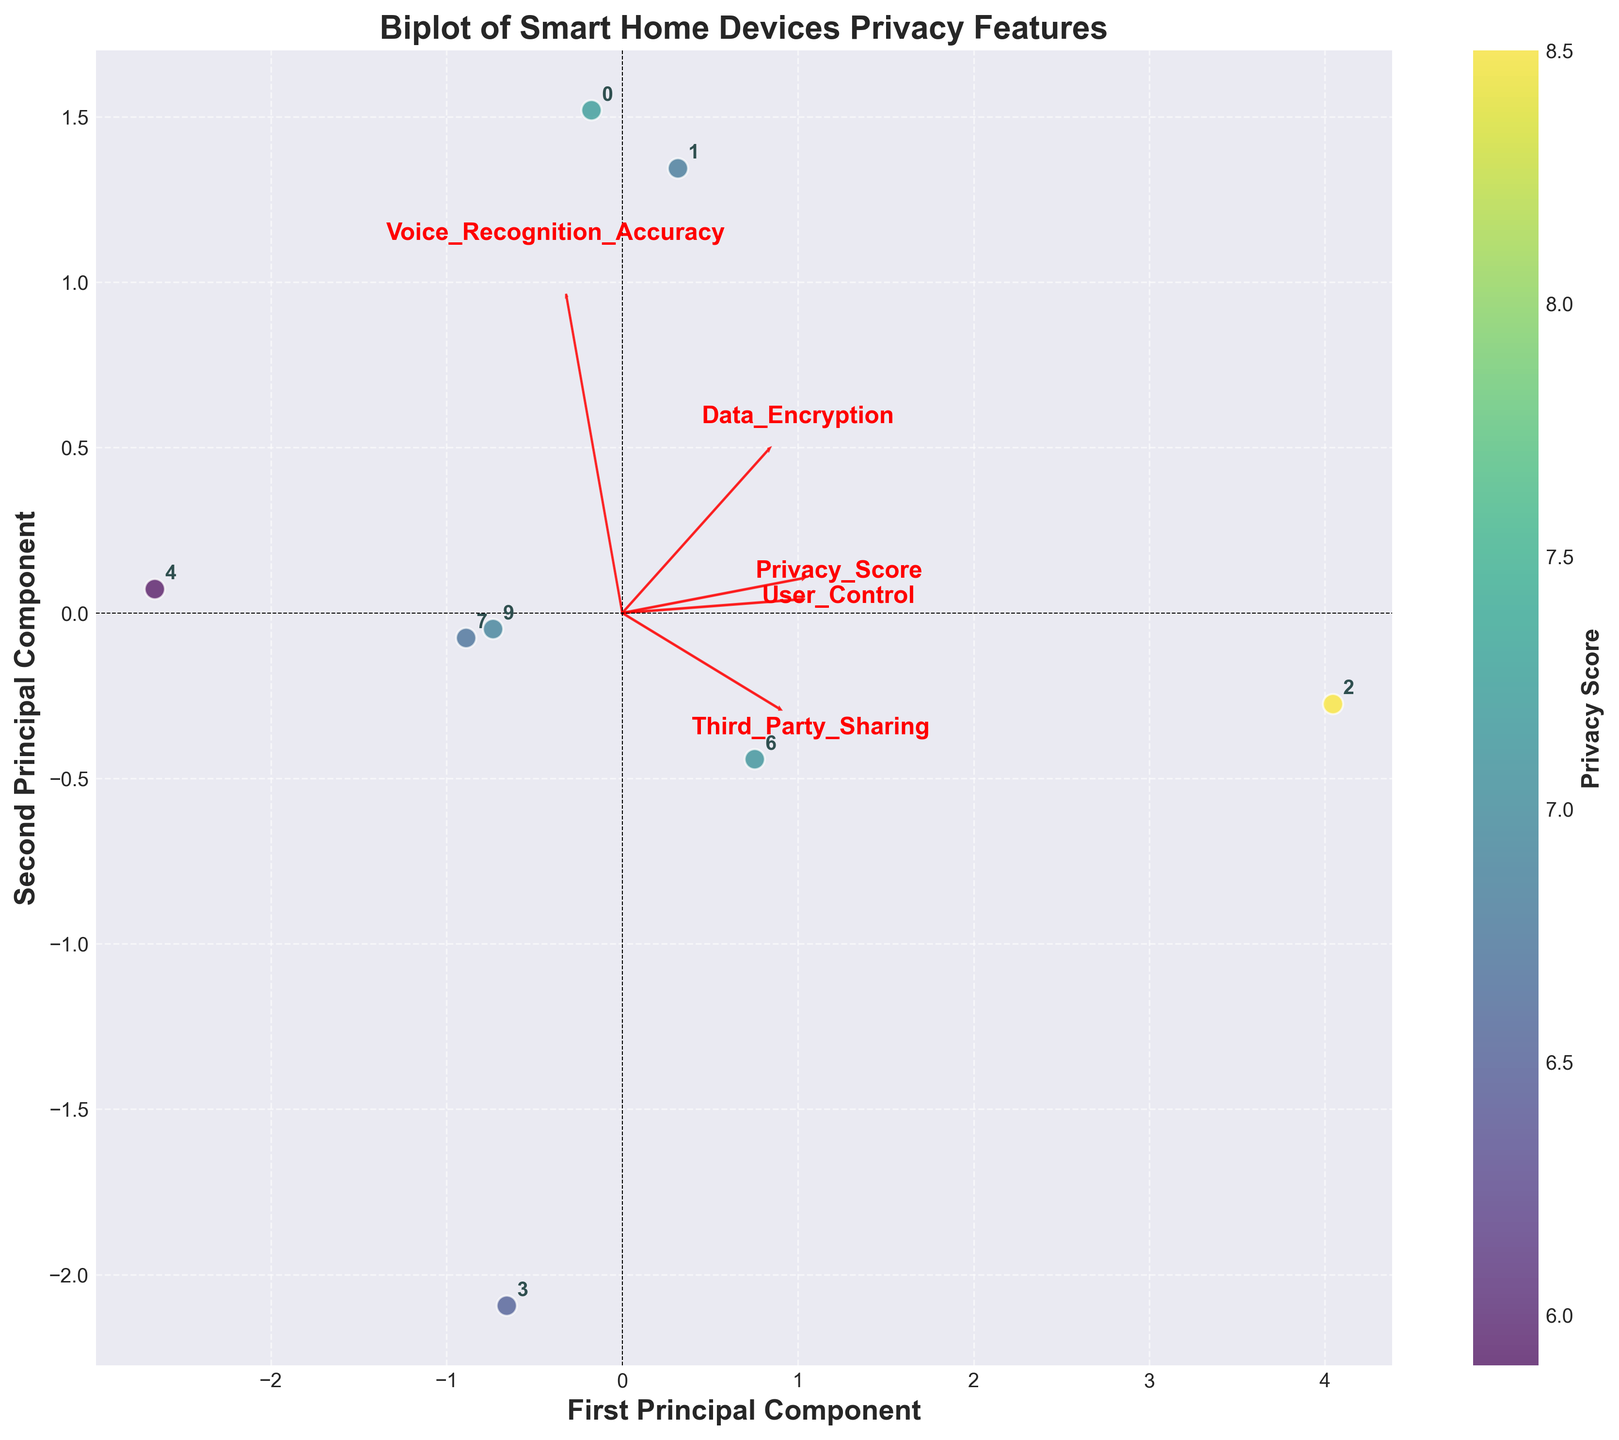What title is given to the plot? The title is prominently displayed at the top of the figure.
Answer: Biplot of Smart Home Devices Privacy Features How many principal components are plotted on the axes? The axes are labeled with "First Principal Component" and "Second Principal Component," indicating two principal components.
Answer: Two Which device has the highest Privacy Score indicated by the color gradient? By looking at the color gradient and the scatter points, the device with the highest Privacy Score corresponds to the darkest color.
Answer: Apple HomePod How does "Voice Recognition Accuracy" relate to the principal components? The feature loadings for "Voice Recognition Accuracy" can be determined by the red arrow labeled accordingly.
Answer: It points towards the first principal component Which two features are most closely aligned with the first principal component? The direction and length of the red arrows indicate the alignments of features with the principal components.
Answer: Data Encryption and Voice Recognition Accuracy What is the general direction of the "Third Party Sharing" feature relative to the principal components? The red arrow for "Third Party Sharing" shows its direction with respect to the origin.
Answer: Mostly along the second principal component Where is the "Samsung SmartThings Hub" located in the context of the principal components? The labeled scatter plot points can be identified with the X and Y coordinates for the Samsung SmartThings Hub.
Answer: Slightly negative in the first, slightly negative in the second principal component How does the "Apple HomePod" compare to the "Ring Video Doorbell" in terms of Privacy Score and principal components? Both devices can be compared by looking at their scatter points and the color gradient representing Privacy Scores.
Answer: Apple HomePod has a higher Privacy Score and is positioned differently in the principal components space Which feature appears to negatively correlate with "User Control"? Observe the direction of the red arrows for both "User Control" and the feature in question; features pointing in opposite directions are negatively correlated.
Answer: Third Party Sharing How is the plot's color gradient used to represent the data? Examine the color gradient bar and the color of the scatter points to understand the representation.
Answer: It represents the Privacy Score 